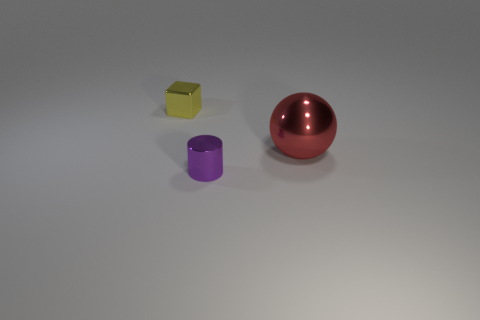Add 3 large purple shiny cylinders. How many objects exist? 6 Subtract all balls. How many objects are left? 2 Add 2 large metallic balls. How many large metallic balls exist? 3 Subtract 0 gray cylinders. How many objects are left? 3 Subtract all small blocks. Subtract all tiny shiny objects. How many objects are left? 0 Add 2 small purple cylinders. How many small purple cylinders are left? 3 